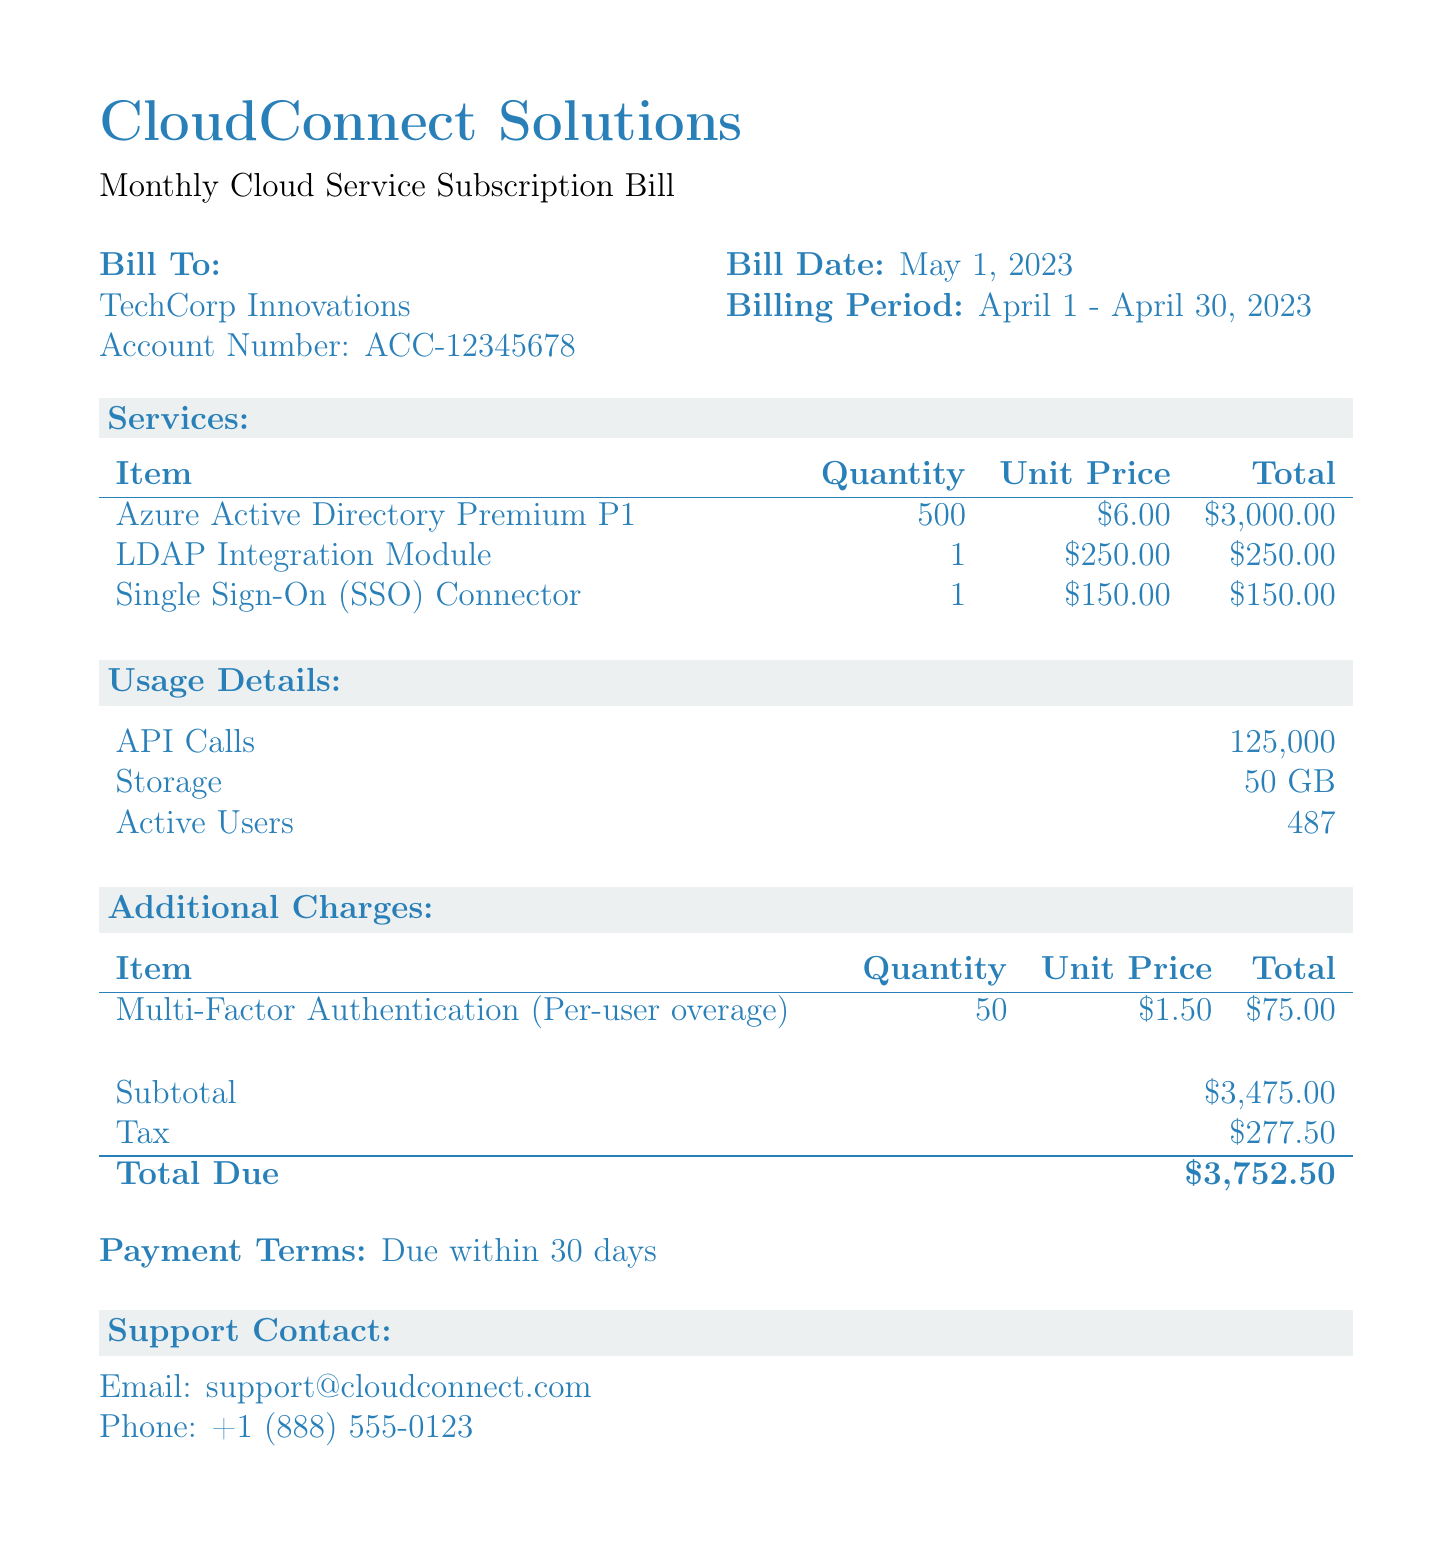What is the account number? The account number is provided in the bill details, which is ACC-12345678.
Answer: ACC-12345678 What is the billing period? The billing period specifies the duration the bill covers, which is from April 1 to April 30, 2023.
Answer: April 1 - April 30, 2023 How many API calls were made? The document lists the total API calls under usage details, which is indicated as 125,000.
Answer: 125,000 What is the subtotal for the services? The subtotal is calculated from the total services before tax and additional charges, which is $3,475.00.
Answer: $3,475.00 What is the total due amount? The total due amount includes the subtotal and tax, which totals $3,752.50.
Answer: $3,752.50 How many active users are listed? The number of active users is specified in the usage details section, which reads 487.
Answer: 487 What additional charge is mentioned? The additional charge provided in the document is for Multi-Factor Authentication (Per-user overage).
Answer: Multi-Factor Authentication (Per-user overage) What is the unit price of the LDAP Integration Module? The unit price for the LDAP Integration Module is specified in the itemized services list as $250.00.
Answer: $250.00 What are the payment terms? The payment terms indicate how long the client has to pay the bill, which is due within 30 days.
Answer: Due within 30 days 